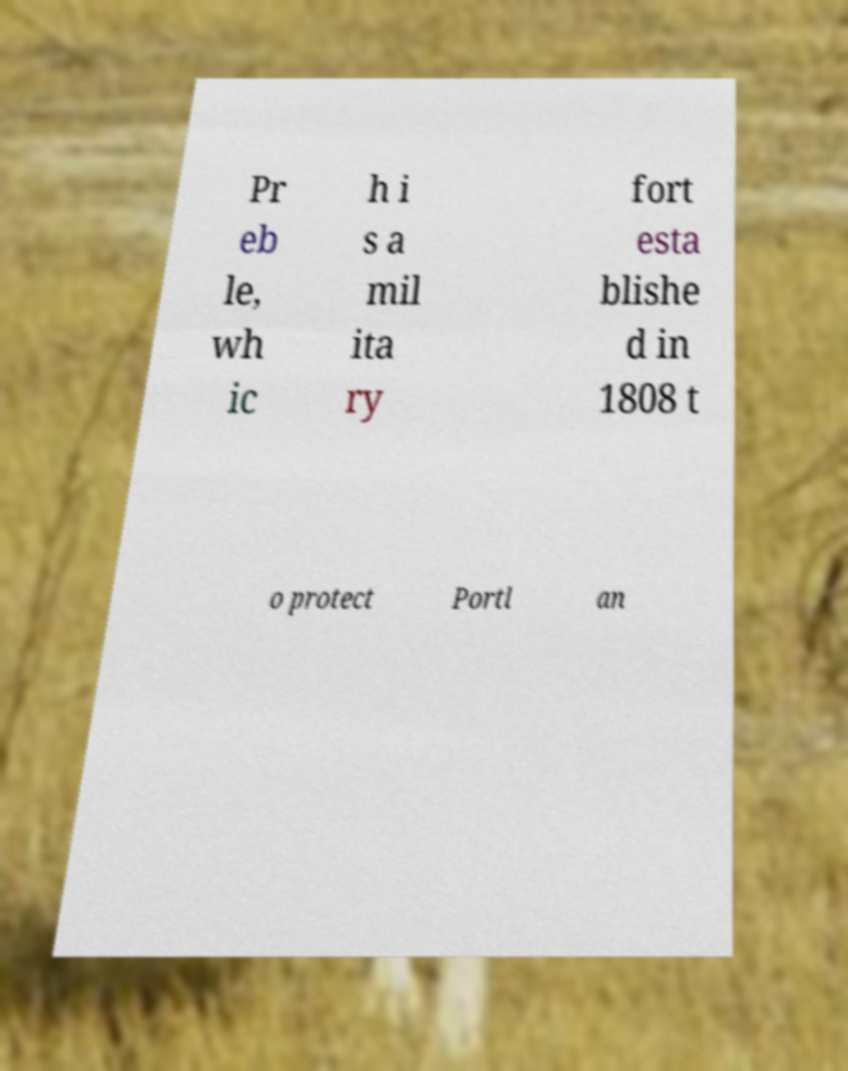Can you accurately transcribe the text from the provided image for me? Pr eb le, wh ic h i s a mil ita ry fort esta blishe d in 1808 t o protect Portl an 